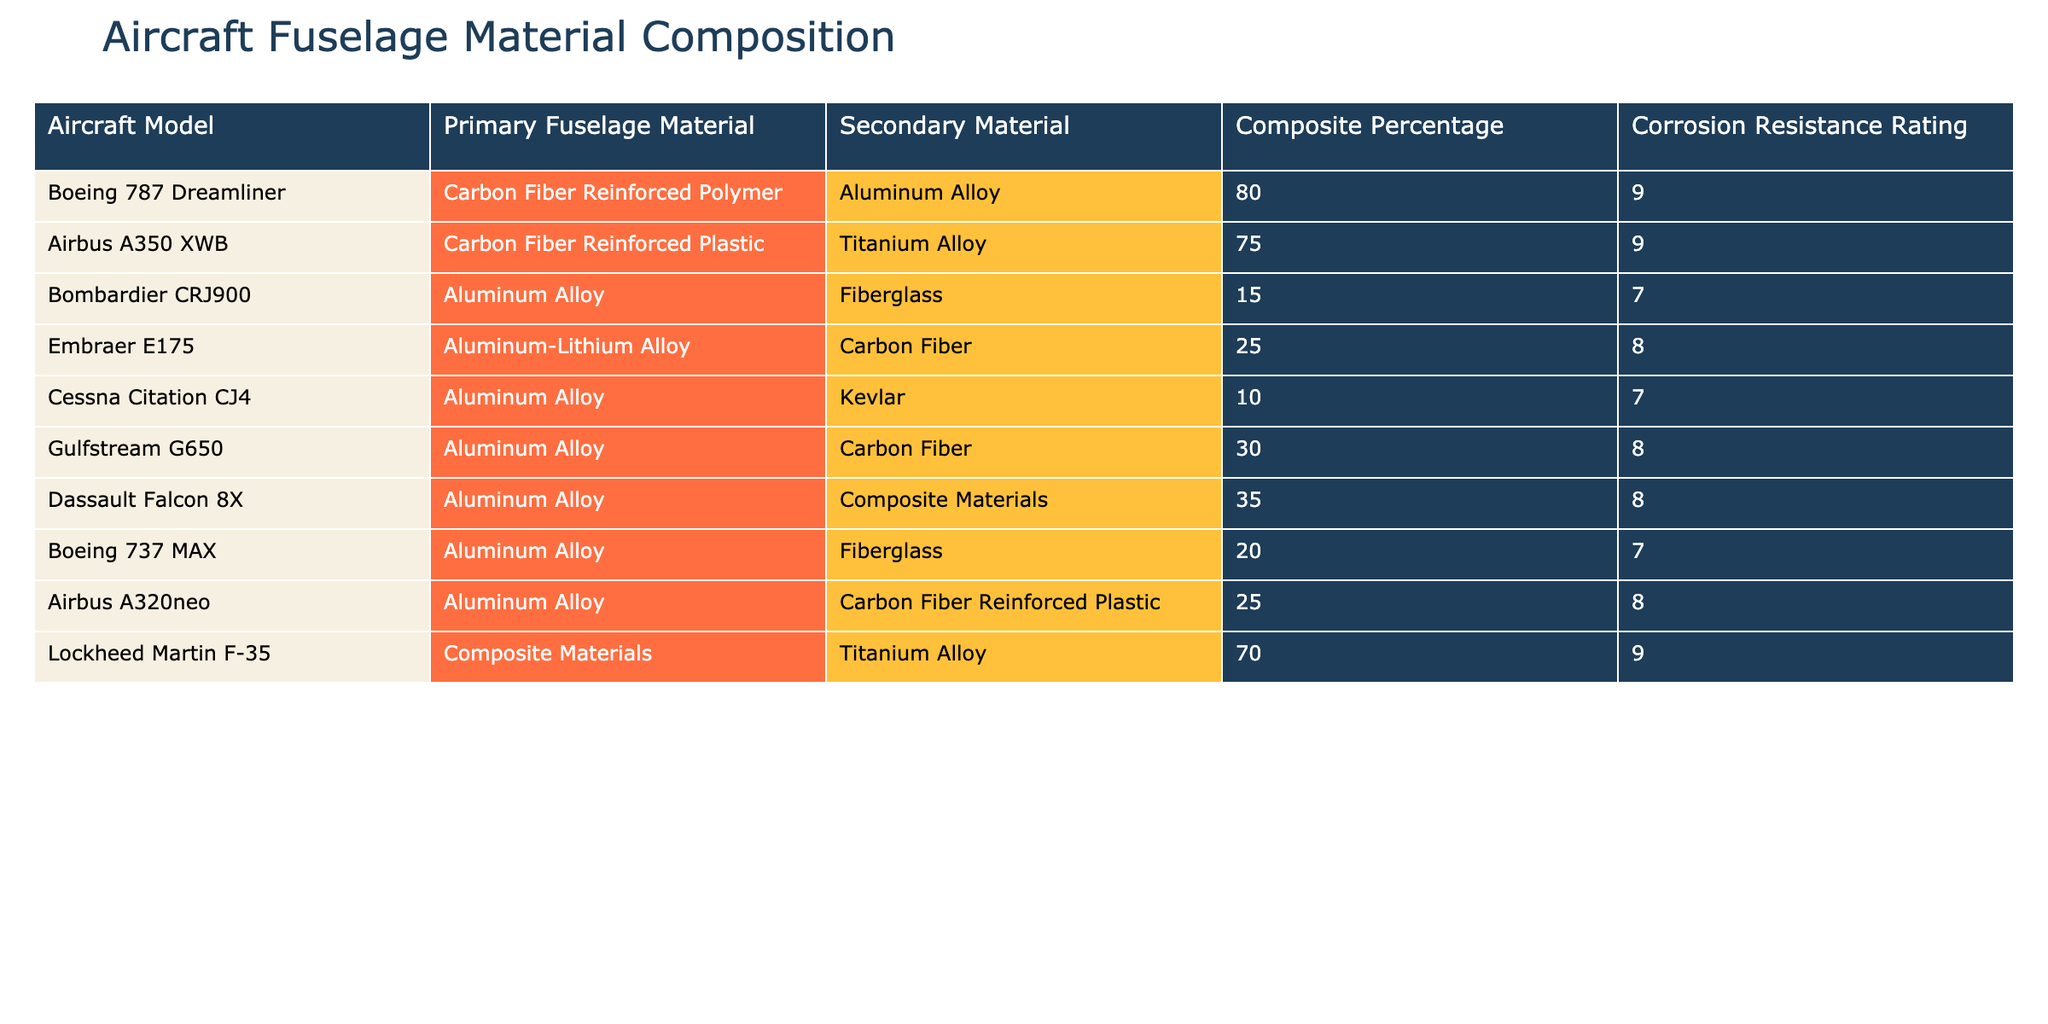What is the primary fuselage material of the Airbus A350 XWB? The table lists the primary fuselage material for each aircraft model. For the Airbus A350 XWB, the primary material is Carbon Fiber Reinforced Plastic.
Answer: Carbon Fiber Reinforced Plastic Which aircraft has the highest composite percentage in its fuselage material? The composite percentage is listed under the respective column. By reviewing the table, the Boeing 787 Dreamliner holds the highest composite percentage at 80%.
Answer: 80% How many aircraft models use Aluminum Alloy as a primary fuselage material? The table can be scanned for the number of times Aluminum Alloy appears in the Primary Fuselage Material column. It appears 6 times for different aircraft models.
Answer: 6 Is the corrosion resistance rating for the Gulfstream G650 higher than 8? The table shows a corrosion resistance rating of 8 for the Gulfstream G650. Therefore, the rating is not higher than 8.
Answer: No What is the average composite percentage of all aircraft models listed? To find the average, sum up the composite percentages (80 + 75 + 15 + 25 + 10 + 30 + 35 + 20 + 25 + 70 =  385) and divide by the number of models (10). The average is 385 / 10 = 38.5.
Answer: 38.5 Does any aircraft model have both Aluminum Alloy as the primary material and a corrosion resistance rating of 9? The table needs to be reviewed for aircraft with Aluminum Alloy as primary material and their ratings. Only the Boeing 787 Dreamliner has a rating of 9. Thus, the answer is yes.
Answer: Yes Which aircraft has a secondary material of Titanium Alloy? Scanning the table for secondary materials reveals that only the Airbus A350 XWB has Titanium Alloy as a secondary material.
Answer: Airbus A350 XWB What is the difference in corrosion resistance rating between the Boeing 737 MAX and the Cessna Citation CJ4? The corrosion resistance rating for Boeing 737 MAX is 7 while for Cessna Citation CJ4 it is also 7. The difference is 7 - 7 = 0.
Answer: 0 Which aircraft has the lowest secondary material composition? By checking the secondary materials listed, the Cessna Citation CJ4 has Kevlar, which has the lowest composition percentage at 10%.
Answer: Cessna Citation CJ4 If you combine the composite percentages of the Boeing 787 Dreamliner and the Lockheed Martin F-35, what is the total? The composite percentage for Boeing 787 Dreamliner is 80% and for Lockheed Martin F-35 it is 70%. Adding them together gives 80 + 70 = 150.
Answer: 150 